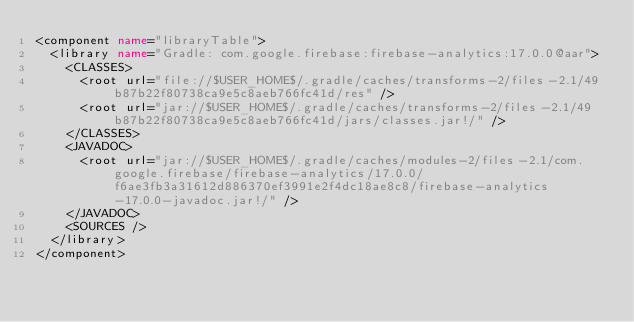<code> <loc_0><loc_0><loc_500><loc_500><_XML_><component name="libraryTable">
  <library name="Gradle: com.google.firebase:firebase-analytics:17.0.0@aar">
    <CLASSES>
      <root url="file://$USER_HOME$/.gradle/caches/transforms-2/files-2.1/49b87b22f80738ca9e5c8aeb766fc41d/res" />
      <root url="jar://$USER_HOME$/.gradle/caches/transforms-2/files-2.1/49b87b22f80738ca9e5c8aeb766fc41d/jars/classes.jar!/" />
    </CLASSES>
    <JAVADOC>
      <root url="jar://$USER_HOME$/.gradle/caches/modules-2/files-2.1/com.google.firebase/firebase-analytics/17.0.0/f6ae3fb3a31612d886370ef3991e2f4dc18ae8c8/firebase-analytics-17.0.0-javadoc.jar!/" />
    </JAVADOC>
    <SOURCES />
  </library>
</component></code> 